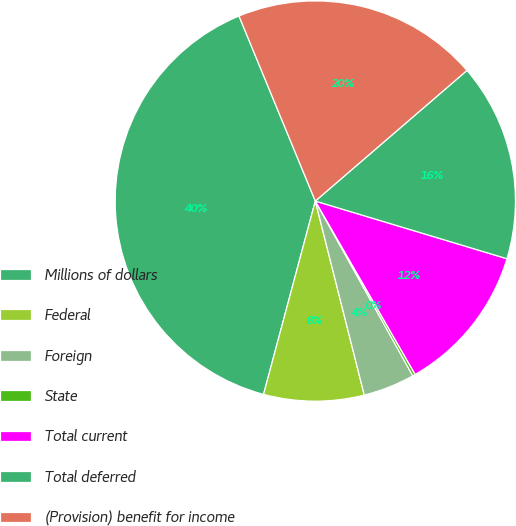Convert chart. <chart><loc_0><loc_0><loc_500><loc_500><pie_chart><fcel>Millions of dollars<fcel>Federal<fcel>Foreign<fcel>State<fcel>Total current<fcel>Total deferred<fcel>(Provision) benefit for income<nl><fcel>39.61%<fcel>8.1%<fcel>4.16%<fcel>0.22%<fcel>12.03%<fcel>15.97%<fcel>19.91%<nl></chart> 